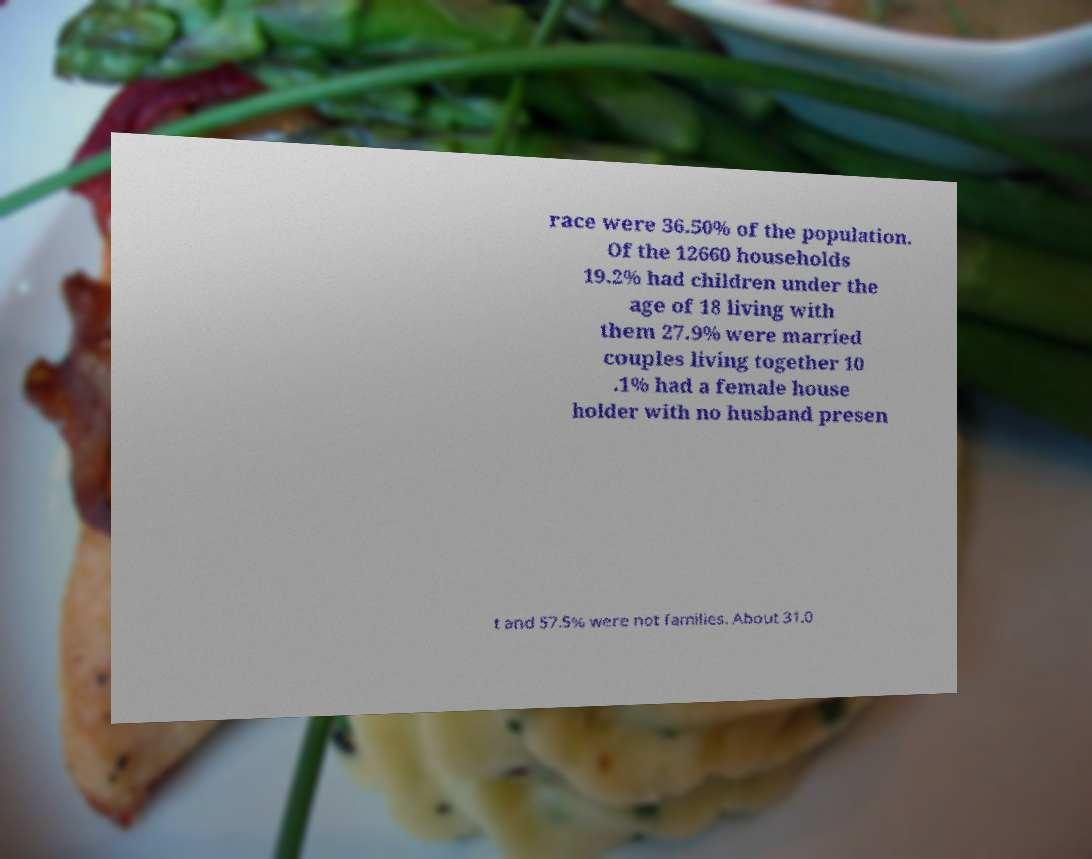What messages or text are displayed in this image? I need them in a readable, typed format. race were 36.50% of the population. Of the 12660 households 19.2% had children under the age of 18 living with them 27.9% were married couples living together 10 .1% had a female house holder with no husband presen t and 57.5% were not families. About 31.0 